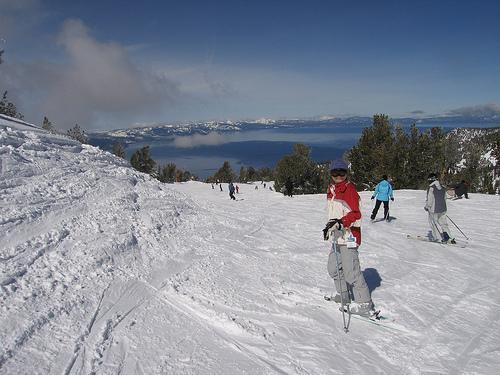How many people are there?
Give a very brief answer. 3. 